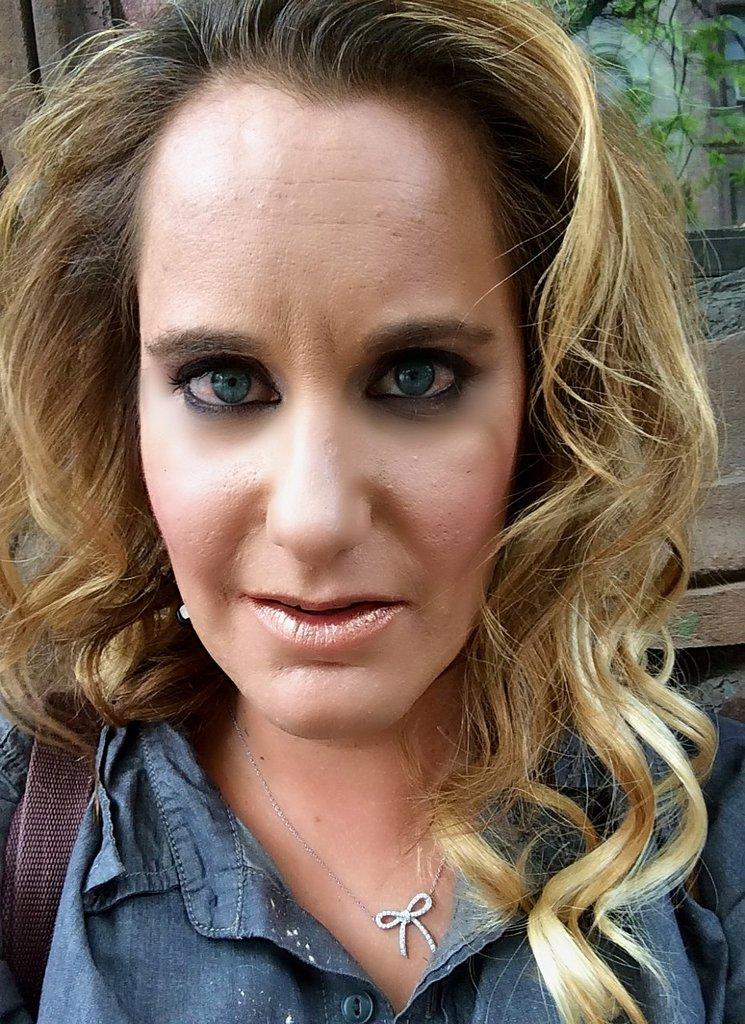Who is the main subject in the foreground of the picture? There is a woman in the foreground of the picture. What is the woman wearing in the image? The woman is wearing a blue shirt and a bag. Can you describe the woman's hair color? The woman has blonde colored hair. What can be seen in the background of the picture? There is a building and a tree in the background of the picture. What type of holiday is the woman celebrating in the image? There is no indication of a holiday in the image; it simply shows a woman wearing a blue shirt, a bag, and having blonde hair. What type of collar is visible on the woman's shirt in the image? There is no collar visible on the woman's shirt in the image; it is a simple blue shirt. 